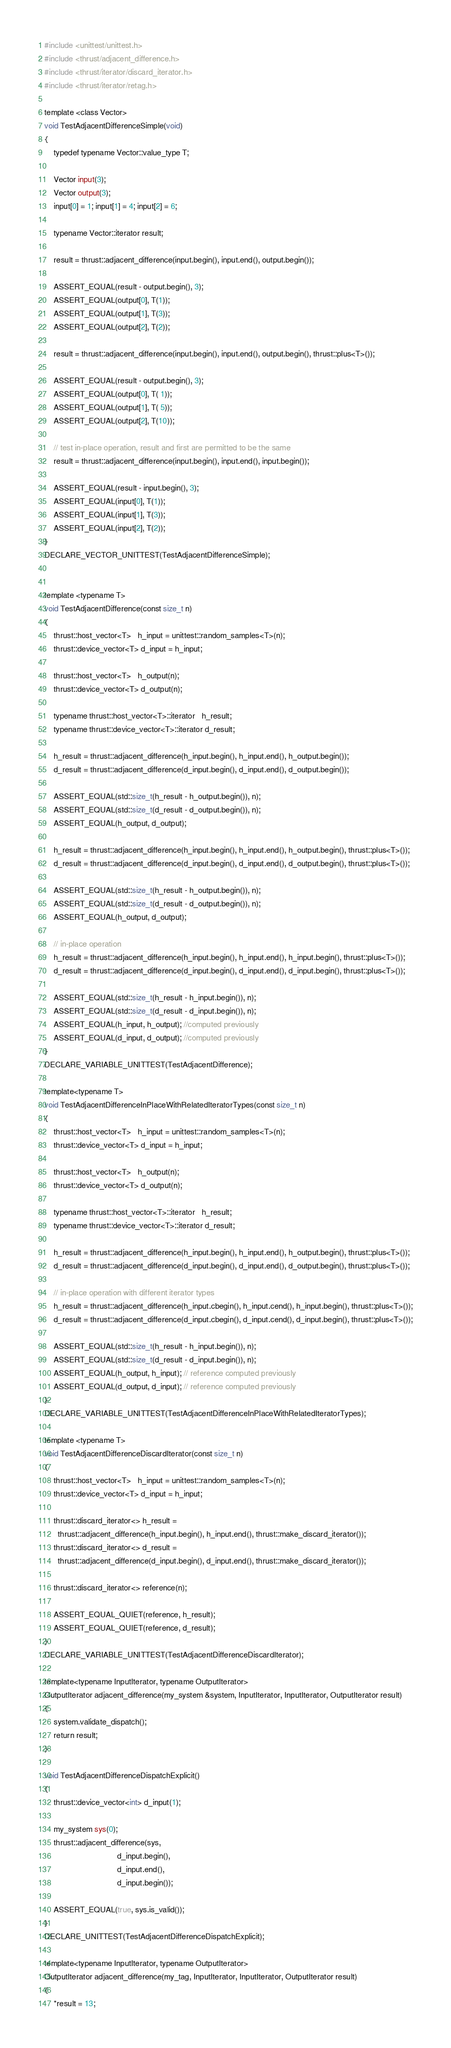<code> <loc_0><loc_0><loc_500><loc_500><_Cuda_>#include <unittest/unittest.h>
#include <thrust/adjacent_difference.h>
#include <thrust/iterator/discard_iterator.h>
#include <thrust/iterator/retag.h>

template <class Vector>
void TestAdjacentDifferenceSimple(void)
{
    typedef typename Vector::value_type T;

    Vector input(3);
    Vector output(3);
    input[0] = 1; input[1] = 4; input[2] = 6;

    typename Vector::iterator result;
    
    result = thrust::adjacent_difference(input.begin(), input.end(), output.begin());

    ASSERT_EQUAL(result - output.begin(), 3);
    ASSERT_EQUAL(output[0], T(1));
    ASSERT_EQUAL(output[1], T(3));
    ASSERT_EQUAL(output[2], T(2));
    
    result = thrust::adjacent_difference(input.begin(), input.end(), output.begin(), thrust::plus<T>());
    
    ASSERT_EQUAL(result - output.begin(), 3);
    ASSERT_EQUAL(output[0], T( 1));
    ASSERT_EQUAL(output[1], T( 5));
    ASSERT_EQUAL(output[2], T(10));
    
    // test in-place operation, result and first are permitted to be the same
    result = thrust::adjacent_difference(input.begin(), input.end(), input.begin());

    ASSERT_EQUAL(result - input.begin(), 3);
    ASSERT_EQUAL(input[0], T(1));
    ASSERT_EQUAL(input[1], T(3));
    ASSERT_EQUAL(input[2], T(2));
}
DECLARE_VECTOR_UNITTEST(TestAdjacentDifferenceSimple);


template <typename T>
void TestAdjacentDifference(const size_t n)
{
    thrust::host_vector<T>   h_input = unittest::random_samples<T>(n);
    thrust::device_vector<T> d_input = h_input;

    thrust::host_vector<T>   h_output(n);
    thrust::device_vector<T> d_output(n);

    typename thrust::host_vector<T>::iterator   h_result;
    typename thrust::device_vector<T>::iterator d_result;

    h_result = thrust::adjacent_difference(h_input.begin(), h_input.end(), h_output.begin());
    d_result = thrust::adjacent_difference(d_input.begin(), d_input.end(), d_output.begin());

    ASSERT_EQUAL(std::size_t(h_result - h_output.begin()), n);
    ASSERT_EQUAL(std::size_t(d_result - d_output.begin()), n);
    ASSERT_EQUAL(h_output, d_output);
    
    h_result = thrust::adjacent_difference(h_input.begin(), h_input.end(), h_output.begin(), thrust::plus<T>());
    d_result = thrust::adjacent_difference(d_input.begin(), d_input.end(), d_output.begin(), thrust::plus<T>());

    ASSERT_EQUAL(std::size_t(h_result - h_output.begin()), n);
    ASSERT_EQUAL(std::size_t(d_result - d_output.begin()), n);
    ASSERT_EQUAL(h_output, d_output);
    
    // in-place operation
    h_result = thrust::adjacent_difference(h_input.begin(), h_input.end(), h_input.begin(), thrust::plus<T>());
    d_result = thrust::adjacent_difference(d_input.begin(), d_input.end(), d_input.begin(), thrust::plus<T>());

    ASSERT_EQUAL(std::size_t(h_result - h_input.begin()), n);
    ASSERT_EQUAL(std::size_t(d_result - d_input.begin()), n);
    ASSERT_EQUAL(h_input, h_output); //computed previously
    ASSERT_EQUAL(d_input, d_output); //computed previously
}
DECLARE_VARIABLE_UNITTEST(TestAdjacentDifference);

template<typename T>
void TestAdjacentDifferenceInPlaceWithRelatedIteratorTypes(const size_t n)
{
    thrust::host_vector<T>   h_input = unittest::random_samples<T>(n);
    thrust::device_vector<T> d_input = h_input;

    thrust::host_vector<T>   h_output(n);
    thrust::device_vector<T> d_output(n);

    typename thrust::host_vector<T>::iterator   h_result;
    typename thrust::device_vector<T>::iterator d_result;

    h_result = thrust::adjacent_difference(h_input.begin(), h_input.end(), h_output.begin(), thrust::plus<T>());
    d_result = thrust::adjacent_difference(d_input.begin(), d_input.end(), d_output.begin(), thrust::plus<T>());
    
    // in-place operation with different iterator types
    h_result = thrust::adjacent_difference(h_input.cbegin(), h_input.cend(), h_input.begin(), thrust::plus<T>());
    d_result = thrust::adjacent_difference(d_input.cbegin(), d_input.cend(), d_input.begin(), thrust::plus<T>());

    ASSERT_EQUAL(std::size_t(h_result - h_input.begin()), n);
    ASSERT_EQUAL(std::size_t(d_result - d_input.begin()), n);
    ASSERT_EQUAL(h_output, h_input); // reference computed previously
    ASSERT_EQUAL(d_output, d_input); // reference computed previously
}
DECLARE_VARIABLE_UNITTEST(TestAdjacentDifferenceInPlaceWithRelatedIteratorTypes);

template <typename T>
void TestAdjacentDifferenceDiscardIterator(const size_t n)
{
    thrust::host_vector<T>   h_input = unittest::random_samples<T>(n);
    thrust::device_vector<T> d_input = h_input;

    thrust::discard_iterator<> h_result =
      thrust::adjacent_difference(h_input.begin(), h_input.end(), thrust::make_discard_iterator());
    thrust::discard_iterator<> d_result =
      thrust::adjacent_difference(d_input.begin(), d_input.end(), thrust::make_discard_iterator());

    thrust::discard_iterator<> reference(n);

    ASSERT_EQUAL_QUIET(reference, h_result);
    ASSERT_EQUAL_QUIET(reference, d_result);
}
DECLARE_VARIABLE_UNITTEST(TestAdjacentDifferenceDiscardIterator);

template<typename InputIterator, typename OutputIterator>
OutputIterator adjacent_difference(my_system &system, InputIterator, InputIterator, OutputIterator result)
{
    system.validate_dispatch();
    return result;
}

void TestAdjacentDifferenceDispatchExplicit()
{
    thrust::device_vector<int> d_input(1);

    my_system sys(0);
    thrust::adjacent_difference(sys,
                                d_input.begin(),
                                d_input.end(),
                                d_input.begin());

    ASSERT_EQUAL(true, sys.is_valid());
}
DECLARE_UNITTEST(TestAdjacentDifferenceDispatchExplicit);

template<typename InputIterator, typename OutputIterator>
OutputIterator adjacent_difference(my_tag, InputIterator, InputIterator, OutputIterator result)
{
    *result = 13;</code> 